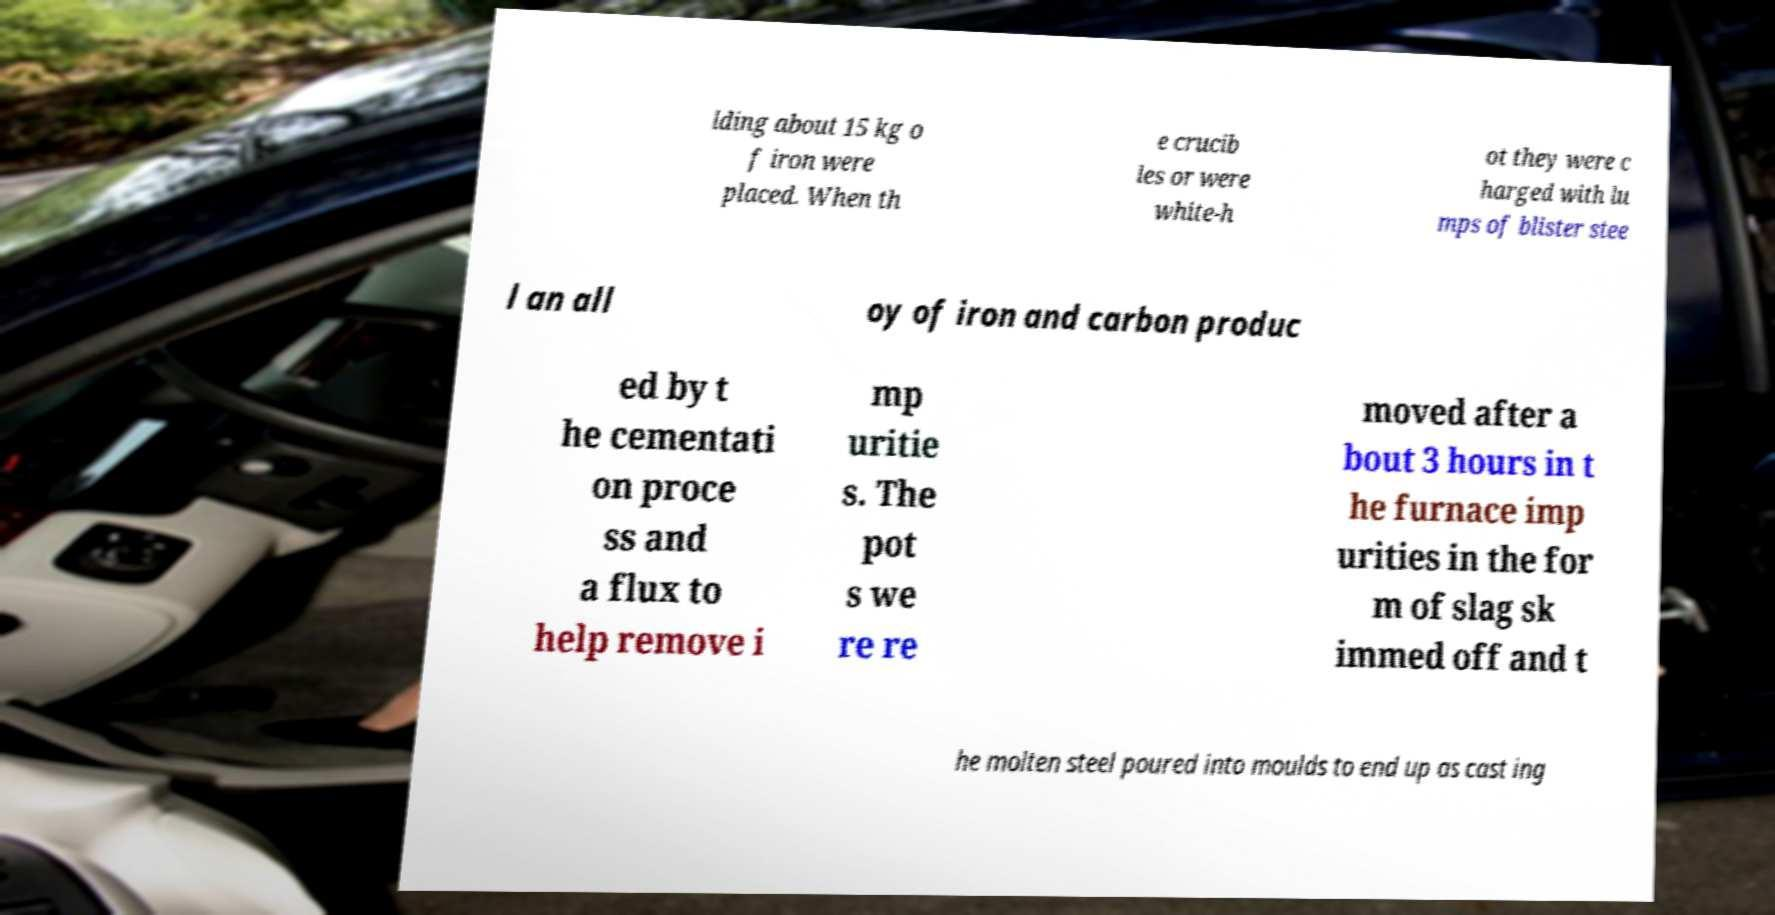Please identify and transcribe the text found in this image. lding about 15 kg o f iron were placed. When th e crucib les or were white-h ot they were c harged with lu mps of blister stee l an all oy of iron and carbon produc ed by t he cementati on proce ss and a flux to help remove i mp uritie s. The pot s we re re moved after a bout 3 hours in t he furnace imp urities in the for m of slag sk immed off and t he molten steel poured into moulds to end up as cast ing 